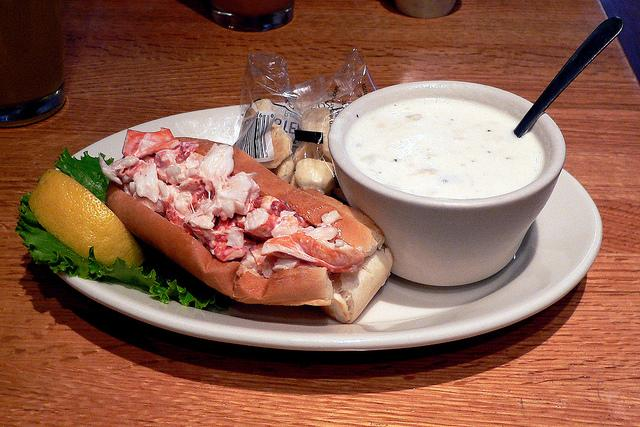What kind of citrus fruit is on top of the leaf on the right side of the white plate?

Choices:
A) lemon
B) grapefruit
C) orange
D) lime lemon 